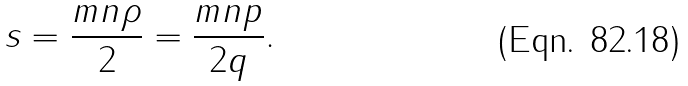Convert formula to latex. <formula><loc_0><loc_0><loc_500><loc_500>s = \frac { m n \rho } { 2 } = \frac { m n p } { 2 q } .</formula> 